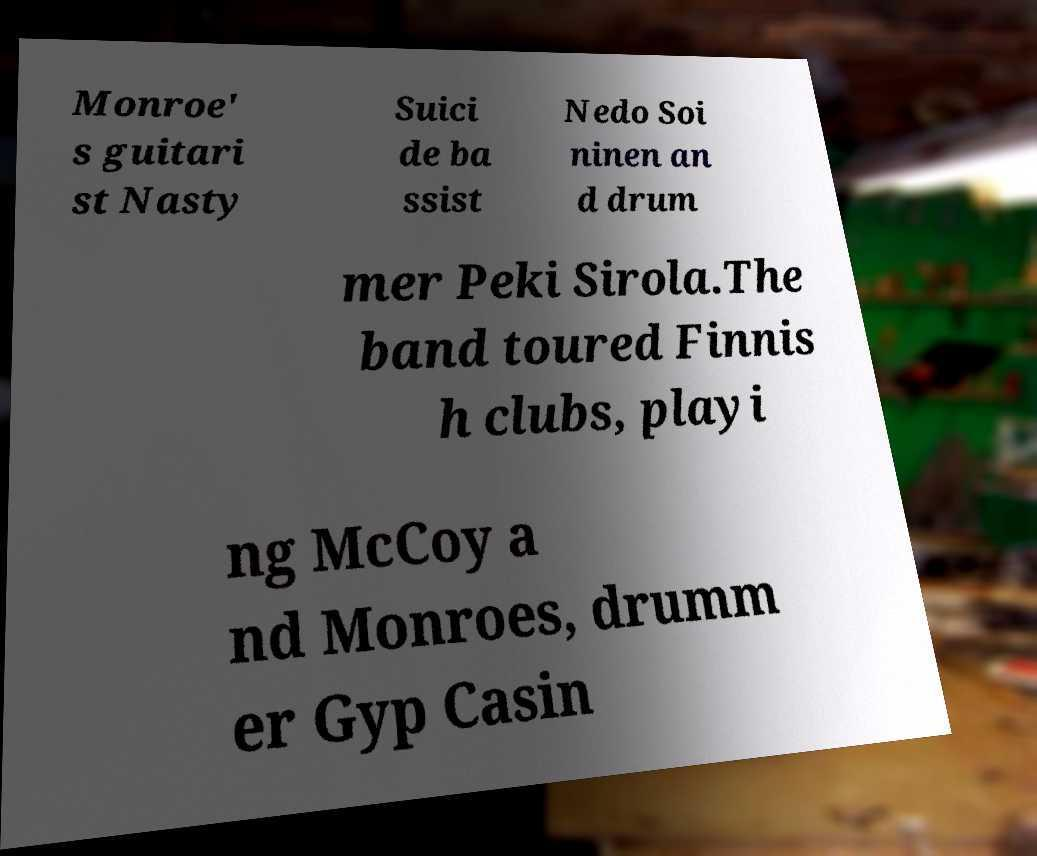Can you read and provide the text displayed in the image?This photo seems to have some interesting text. Can you extract and type it out for me? Monroe' s guitari st Nasty Suici de ba ssist Nedo Soi ninen an d drum mer Peki Sirola.The band toured Finnis h clubs, playi ng McCoy a nd Monroes, drumm er Gyp Casin 